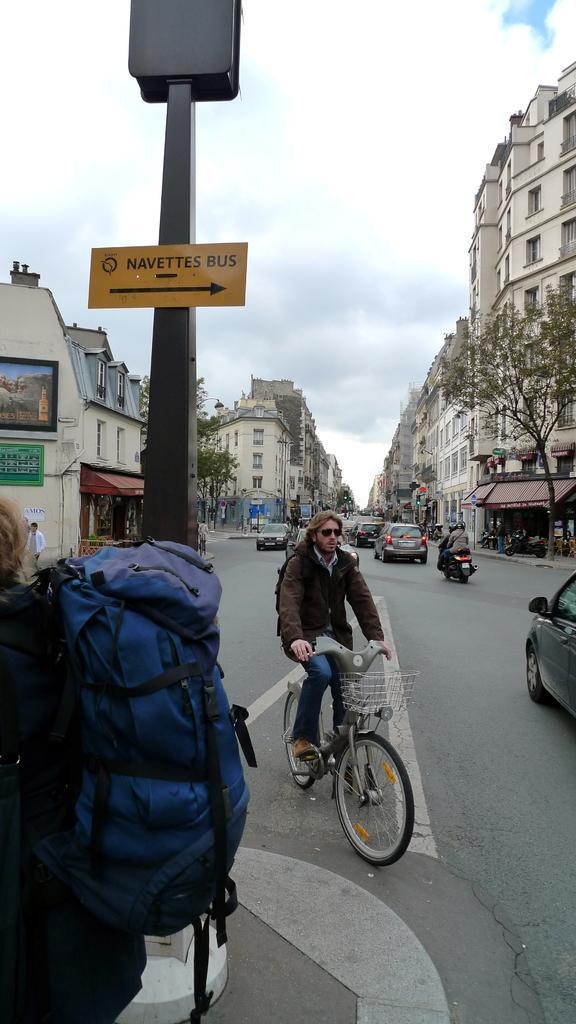Please provide a concise description of this image. In this image we can see a group of vehicles and some people on the road. We can also see a street sign, some boards on a wall, a group of buildings, some trees and the sky which looks cloudy. On the left side we can see a person wearing a bag. 